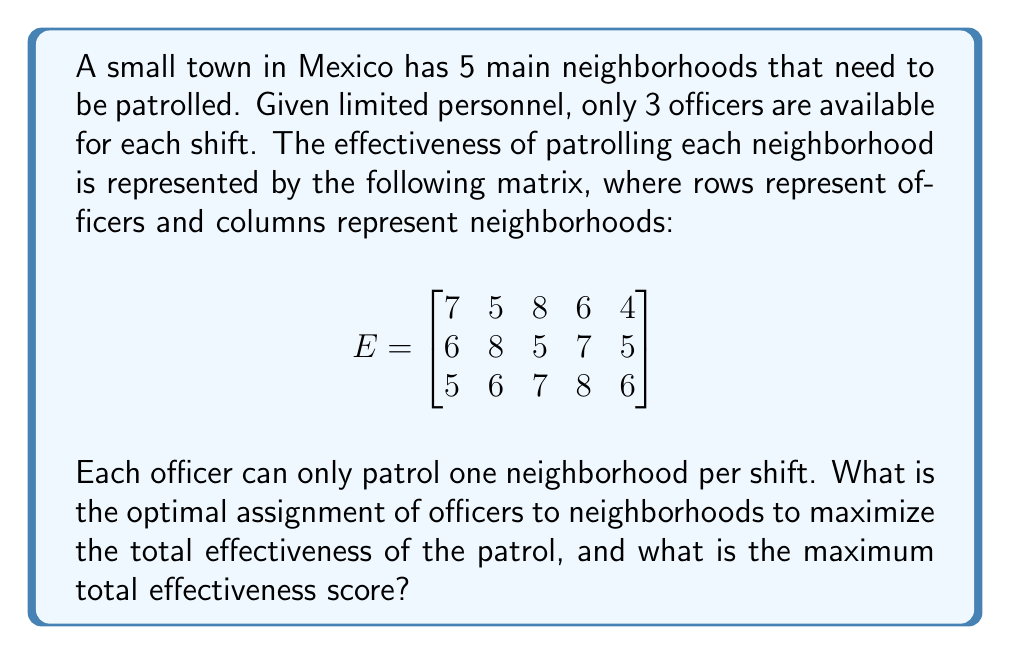Can you answer this question? This problem can be solved using the Hungarian algorithm, which is designed to find the optimal assignment in bipartite matching problems. However, we can also solve it using a simpler approach given the small size of the problem.

1. First, we need to consider all possible combinations of assigning 3 officers to 3 out of 5 neighborhoods. There are $\binom{5}{3} = 10$ such combinations.

2. For each combination, we need to find the best assignment of officers to the selected neighborhoods. This can be done by calculating the sum of effectiveness scores for all permutations of the officers.

3. Let's go through each combination:

   a) Neighborhoods 1, 2, 3:
      Best assignment: Officer 1 to 3, Officer 2 to 2, Officer 3 to 1
      Score: 8 + 8 + 5 = 21

   b) Neighborhoods 1, 2, 4:
      Best assignment: Officer 1 to 1, Officer 2 to 2, Officer 3 to 4
      Score: 7 + 8 + 8 = 23

   c) Neighborhoods 1, 2, 5:
      Best assignment: Officer 1 to 1, Officer 2 to 2, Officer 3 to 5
      Score: 7 + 8 + 6 = 21

   d) Neighborhoods 1, 3, 4:
      Best assignment: Officer 1 to 3, Officer 2 to 4, Officer 3 to 1
      Score: 8 + 7 + 5 = 20

   e) Neighborhoods 1, 3, 5:
      Best assignment: Officer 1 to 3, Officer 2 to 1, Officer 3 to 5
      Score: 8 + 6 + 6 = 20

   f) Neighborhoods 1, 4, 5:
      Best assignment: Officer 1 to 1, Officer 2 to 4, Officer 3 to 5
      Score: 7 + 7 + 6 = 20

   g) Neighborhoods 2, 3, 4:
      Best assignment: Officer 1 to 3, Officer 2 to 2, Officer 3 to 4
      Score: 8 + 8 + 8 = 24

   h) Neighborhoods 2, 3, 5:
      Best assignment: Officer 1 to 3, Officer 2 to 2, Officer 3 to 5
      Score: 8 + 8 + 6 = 22

   i) Neighborhoods 2, 4, 5:
      Best assignment: Officer 1 to 4, Officer 2 to 2, Officer 3 to 5
      Score: 6 + 8 + 6 = 20

   j) Neighborhoods 3, 4, 5:
      Best assignment: Officer 1 to 3, Officer 2 to 4, Officer 3 to 5
      Score: 8 + 7 + 6 = 21

4. The maximum score is 24, achieved by patrolling neighborhoods 2, 3, and 4.
Answer: The optimal assignment is:
Officer 1 patrols neighborhood 3
Officer 2 patrols neighborhood 2
Officer 3 patrols neighborhood 4

The maximum total effectiveness score is 24. 